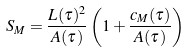<formula> <loc_0><loc_0><loc_500><loc_500>S _ { M } = \frac { L ( \tau ) ^ { 2 } } { A ( \tau ) } \left ( 1 + \frac { c _ { M } ( \tau ) } { A ( \tau ) } \right )</formula> 